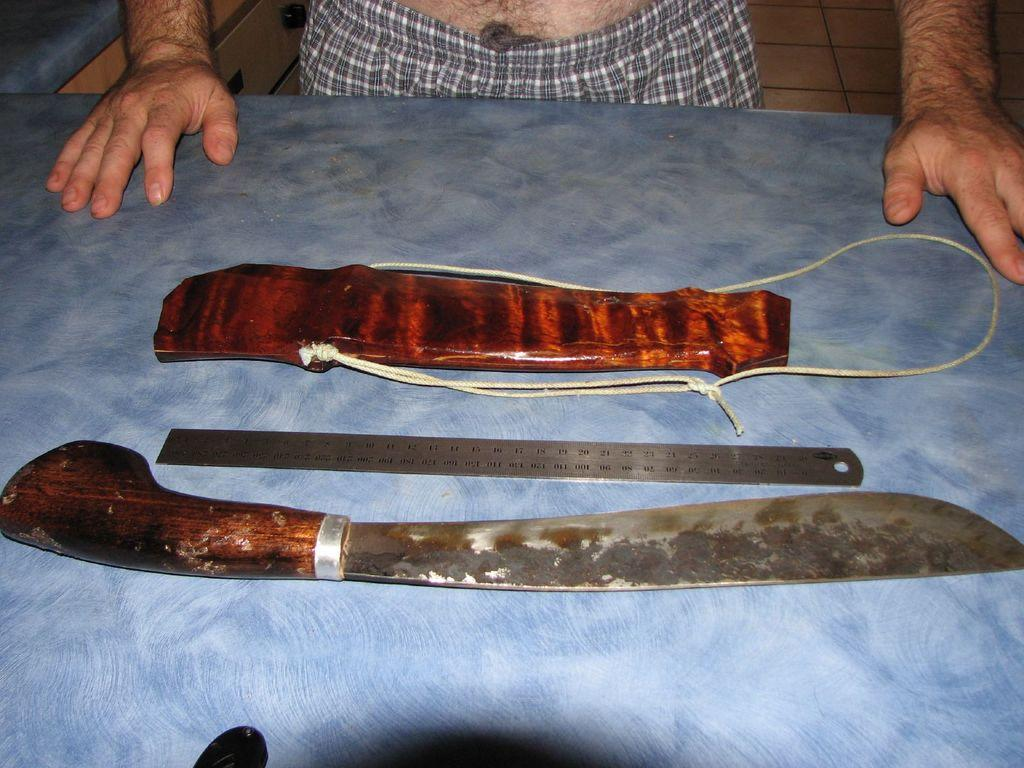What object is present in the image that is typically used for cutting? There is a knife in the image. What device is visible in the image that is used for measuring weight? There is an iron scale in the image. What type of container is present in the image that holds the knife? There appears to be a knife pouch in the image. Whose hands are visible in the image? Human hands are visible in the image. What type of cobweb can be seen in the image? There is no cobweb present in the image. What role does the father play in the scene depicted in the image? There is no father or scene depicted in the image; it only shows a knife, an iron scale, a knife pouch, and human hands. 